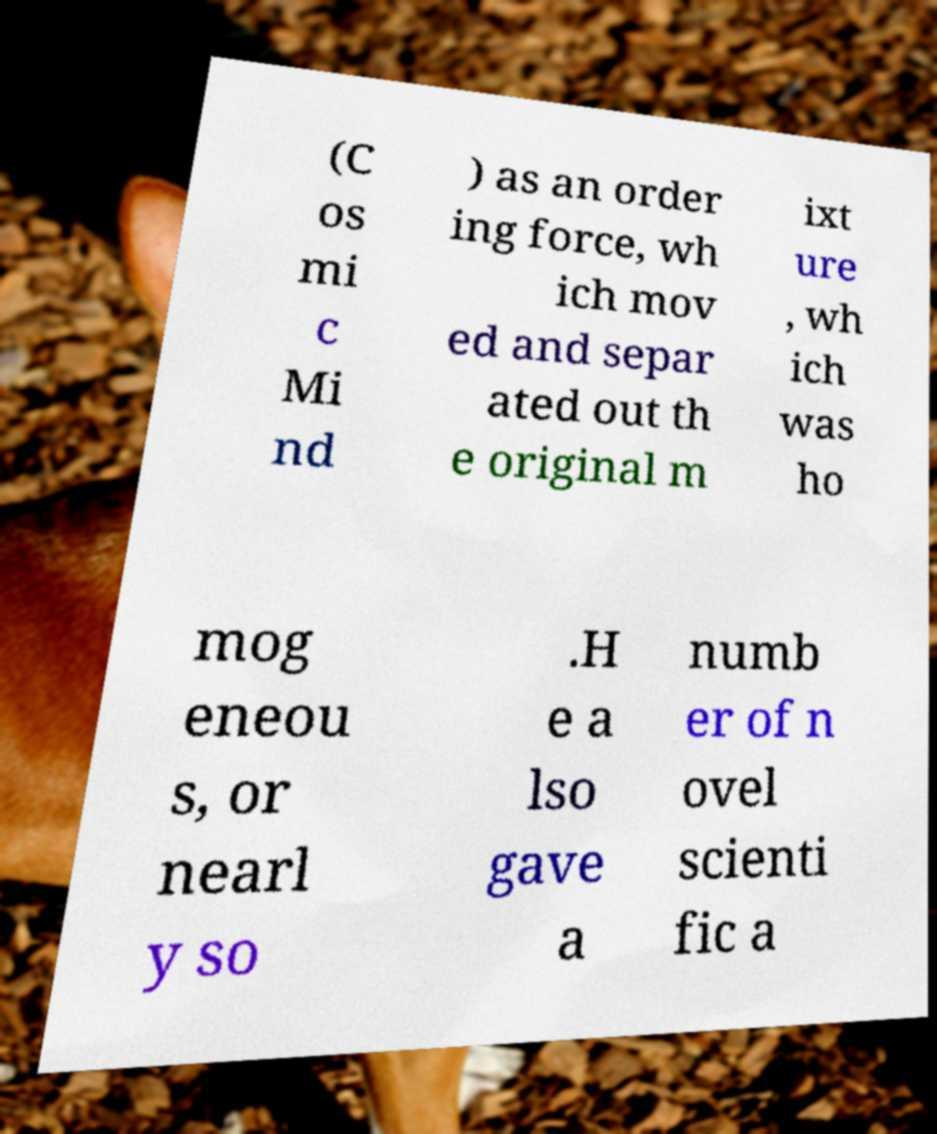What messages or text are displayed in this image? I need them in a readable, typed format. (C os mi c Mi nd ) as an order ing force, wh ich mov ed and separ ated out th e original m ixt ure , wh ich was ho mog eneou s, or nearl y so .H e a lso gave a numb er of n ovel scienti fic a 